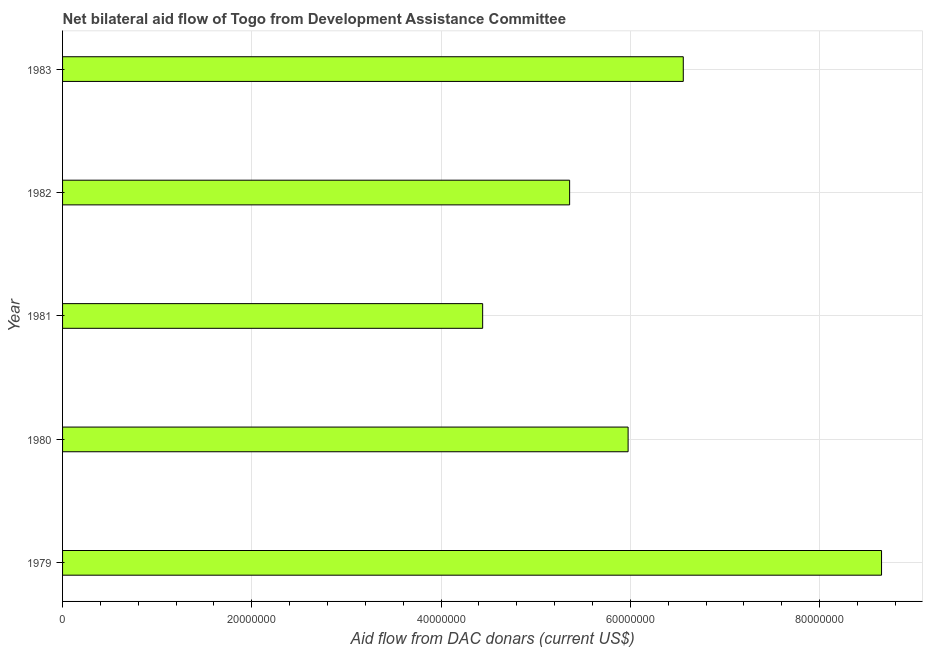Does the graph contain any zero values?
Provide a short and direct response. No. Does the graph contain grids?
Offer a terse response. Yes. What is the title of the graph?
Offer a terse response. Net bilateral aid flow of Togo from Development Assistance Committee. What is the label or title of the X-axis?
Offer a terse response. Aid flow from DAC donars (current US$). What is the label or title of the Y-axis?
Make the answer very short. Year. What is the net bilateral aid flows from dac donors in 1982?
Offer a terse response. 5.36e+07. Across all years, what is the maximum net bilateral aid flows from dac donors?
Offer a very short reply. 8.65e+07. Across all years, what is the minimum net bilateral aid flows from dac donors?
Give a very brief answer. 4.44e+07. In which year was the net bilateral aid flows from dac donors maximum?
Ensure brevity in your answer.  1979. In which year was the net bilateral aid flows from dac donors minimum?
Your response must be concise. 1981. What is the sum of the net bilateral aid flows from dac donors?
Keep it short and to the point. 3.10e+08. What is the difference between the net bilateral aid flows from dac donors in 1980 and 1981?
Your answer should be compact. 1.54e+07. What is the average net bilateral aid flows from dac donors per year?
Provide a succinct answer. 6.20e+07. What is the median net bilateral aid flows from dac donors?
Your response must be concise. 5.98e+07. What is the ratio of the net bilateral aid flows from dac donors in 1979 to that in 1983?
Your answer should be very brief. 1.32. Is the net bilateral aid flows from dac donors in 1979 less than that in 1981?
Your response must be concise. No. Is the difference between the net bilateral aid flows from dac donors in 1979 and 1982 greater than the difference between any two years?
Give a very brief answer. No. What is the difference between the highest and the second highest net bilateral aid flows from dac donors?
Your answer should be very brief. 2.10e+07. Is the sum of the net bilateral aid flows from dac donors in 1979 and 1980 greater than the maximum net bilateral aid flows from dac donors across all years?
Give a very brief answer. Yes. What is the difference between the highest and the lowest net bilateral aid flows from dac donors?
Make the answer very short. 4.22e+07. How many years are there in the graph?
Your answer should be compact. 5. What is the difference between two consecutive major ticks on the X-axis?
Keep it short and to the point. 2.00e+07. Are the values on the major ticks of X-axis written in scientific E-notation?
Provide a succinct answer. No. What is the Aid flow from DAC donars (current US$) in 1979?
Provide a succinct answer. 8.65e+07. What is the Aid flow from DAC donars (current US$) in 1980?
Make the answer very short. 5.98e+07. What is the Aid flow from DAC donars (current US$) in 1981?
Make the answer very short. 4.44e+07. What is the Aid flow from DAC donars (current US$) in 1982?
Your response must be concise. 5.36e+07. What is the Aid flow from DAC donars (current US$) in 1983?
Your answer should be compact. 6.56e+07. What is the difference between the Aid flow from DAC donars (current US$) in 1979 and 1980?
Your answer should be very brief. 2.68e+07. What is the difference between the Aid flow from DAC donars (current US$) in 1979 and 1981?
Your answer should be very brief. 4.22e+07. What is the difference between the Aid flow from DAC donars (current US$) in 1979 and 1982?
Make the answer very short. 3.30e+07. What is the difference between the Aid flow from DAC donars (current US$) in 1979 and 1983?
Give a very brief answer. 2.10e+07. What is the difference between the Aid flow from DAC donars (current US$) in 1980 and 1981?
Provide a succinct answer. 1.54e+07. What is the difference between the Aid flow from DAC donars (current US$) in 1980 and 1982?
Offer a very short reply. 6.18e+06. What is the difference between the Aid flow from DAC donars (current US$) in 1980 and 1983?
Make the answer very short. -5.83e+06. What is the difference between the Aid flow from DAC donars (current US$) in 1981 and 1982?
Your answer should be compact. -9.19e+06. What is the difference between the Aid flow from DAC donars (current US$) in 1981 and 1983?
Offer a very short reply. -2.12e+07. What is the difference between the Aid flow from DAC donars (current US$) in 1982 and 1983?
Provide a succinct answer. -1.20e+07. What is the ratio of the Aid flow from DAC donars (current US$) in 1979 to that in 1980?
Give a very brief answer. 1.45. What is the ratio of the Aid flow from DAC donars (current US$) in 1979 to that in 1981?
Ensure brevity in your answer.  1.95. What is the ratio of the Aid flow from DAC donars (current US$) in 1979 to that in 1982?
Your answer should be compact. 1.61. What is the ratio of the Aid flow from DAC donars (current US$) in 1979 to that in 1983?
Ensure brevity in your answer.  1.32. What is the ratio of the Aid flow from DAC donars (current US$) in 1980 to that in 1981?
Offer a terse response. 1.35. What is the ratio of the Aid flow from DAC donars (current US$) in 1980 to that in 1982?
Give a very brief answer. 1.11. What is the ratio of the Aid flow from DAC donars (current US$) in 1980 to that in 1983?
Your answer should be compact. 0.91. What is the ratio of the Aid flow from DAC donars (current US$) in 1981 to that in 1982?
Your response must be concise. 0.83. What is the ratio of the Aid flow from DAC donars (current US$) in 1981 to that in 1983?
Your response must be concise. 0.68. What is the ratio of the Aid flow from DAC donars (current US$) in 1982 to that in 1983?
Offer a terse response. 0.82. 